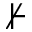<formula> <loc_0><loc_0><loc_500><loc_500>\nvdash</formula> 